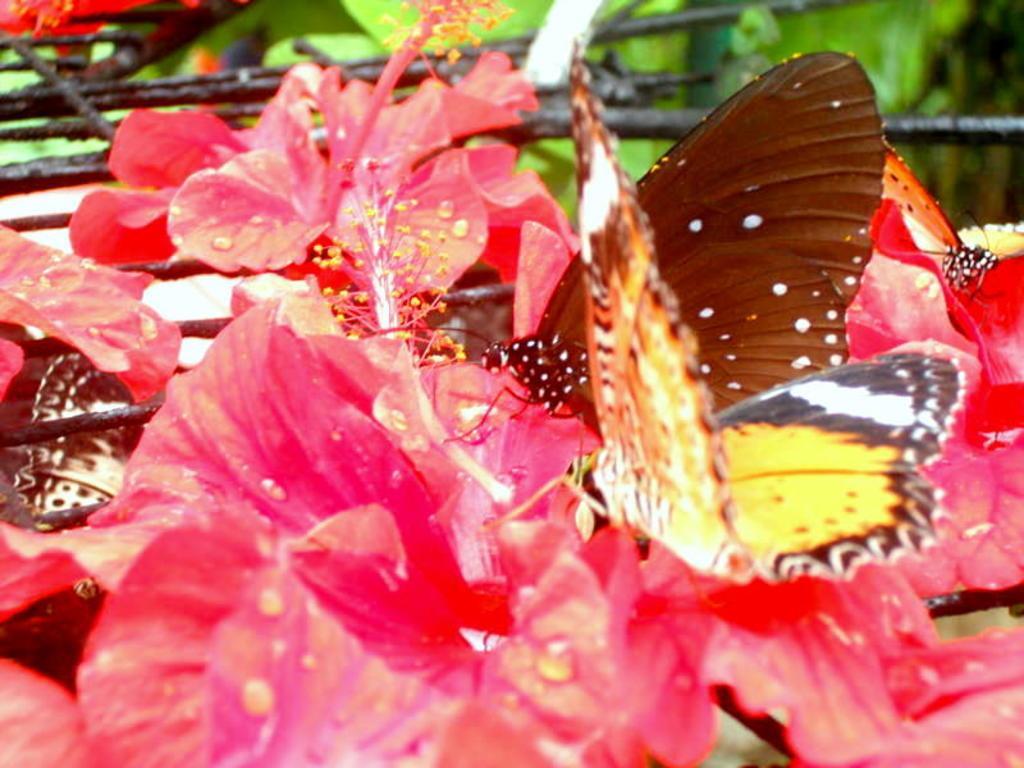Describe this image in one or two sentences. In this image we can see butterflies on flowers. In the background it is blur. 